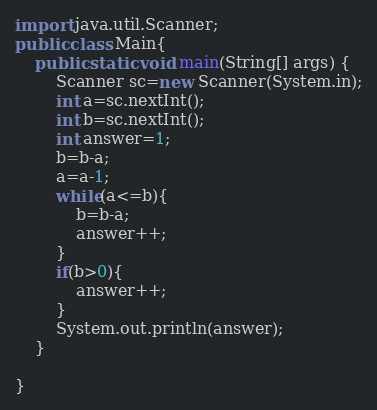<code> <loc_0><loc_0><loc_500><loc_500><_Java_>import java.util.Scanner;
public class Main{
    public static void main(String[] args) {
        Scanner sc=new Scanner(System.in);
        int a=sc.nextInt();
        int b=sc.nextInt();
        int answer=1;
        b=b-a;
        a=a-1;
        while(a<=b){
            b=b-a;
            answer++;
        }
        if(b>0){
            answer++;
        }
        System.out.println(answer);
    }
    
}</code> 